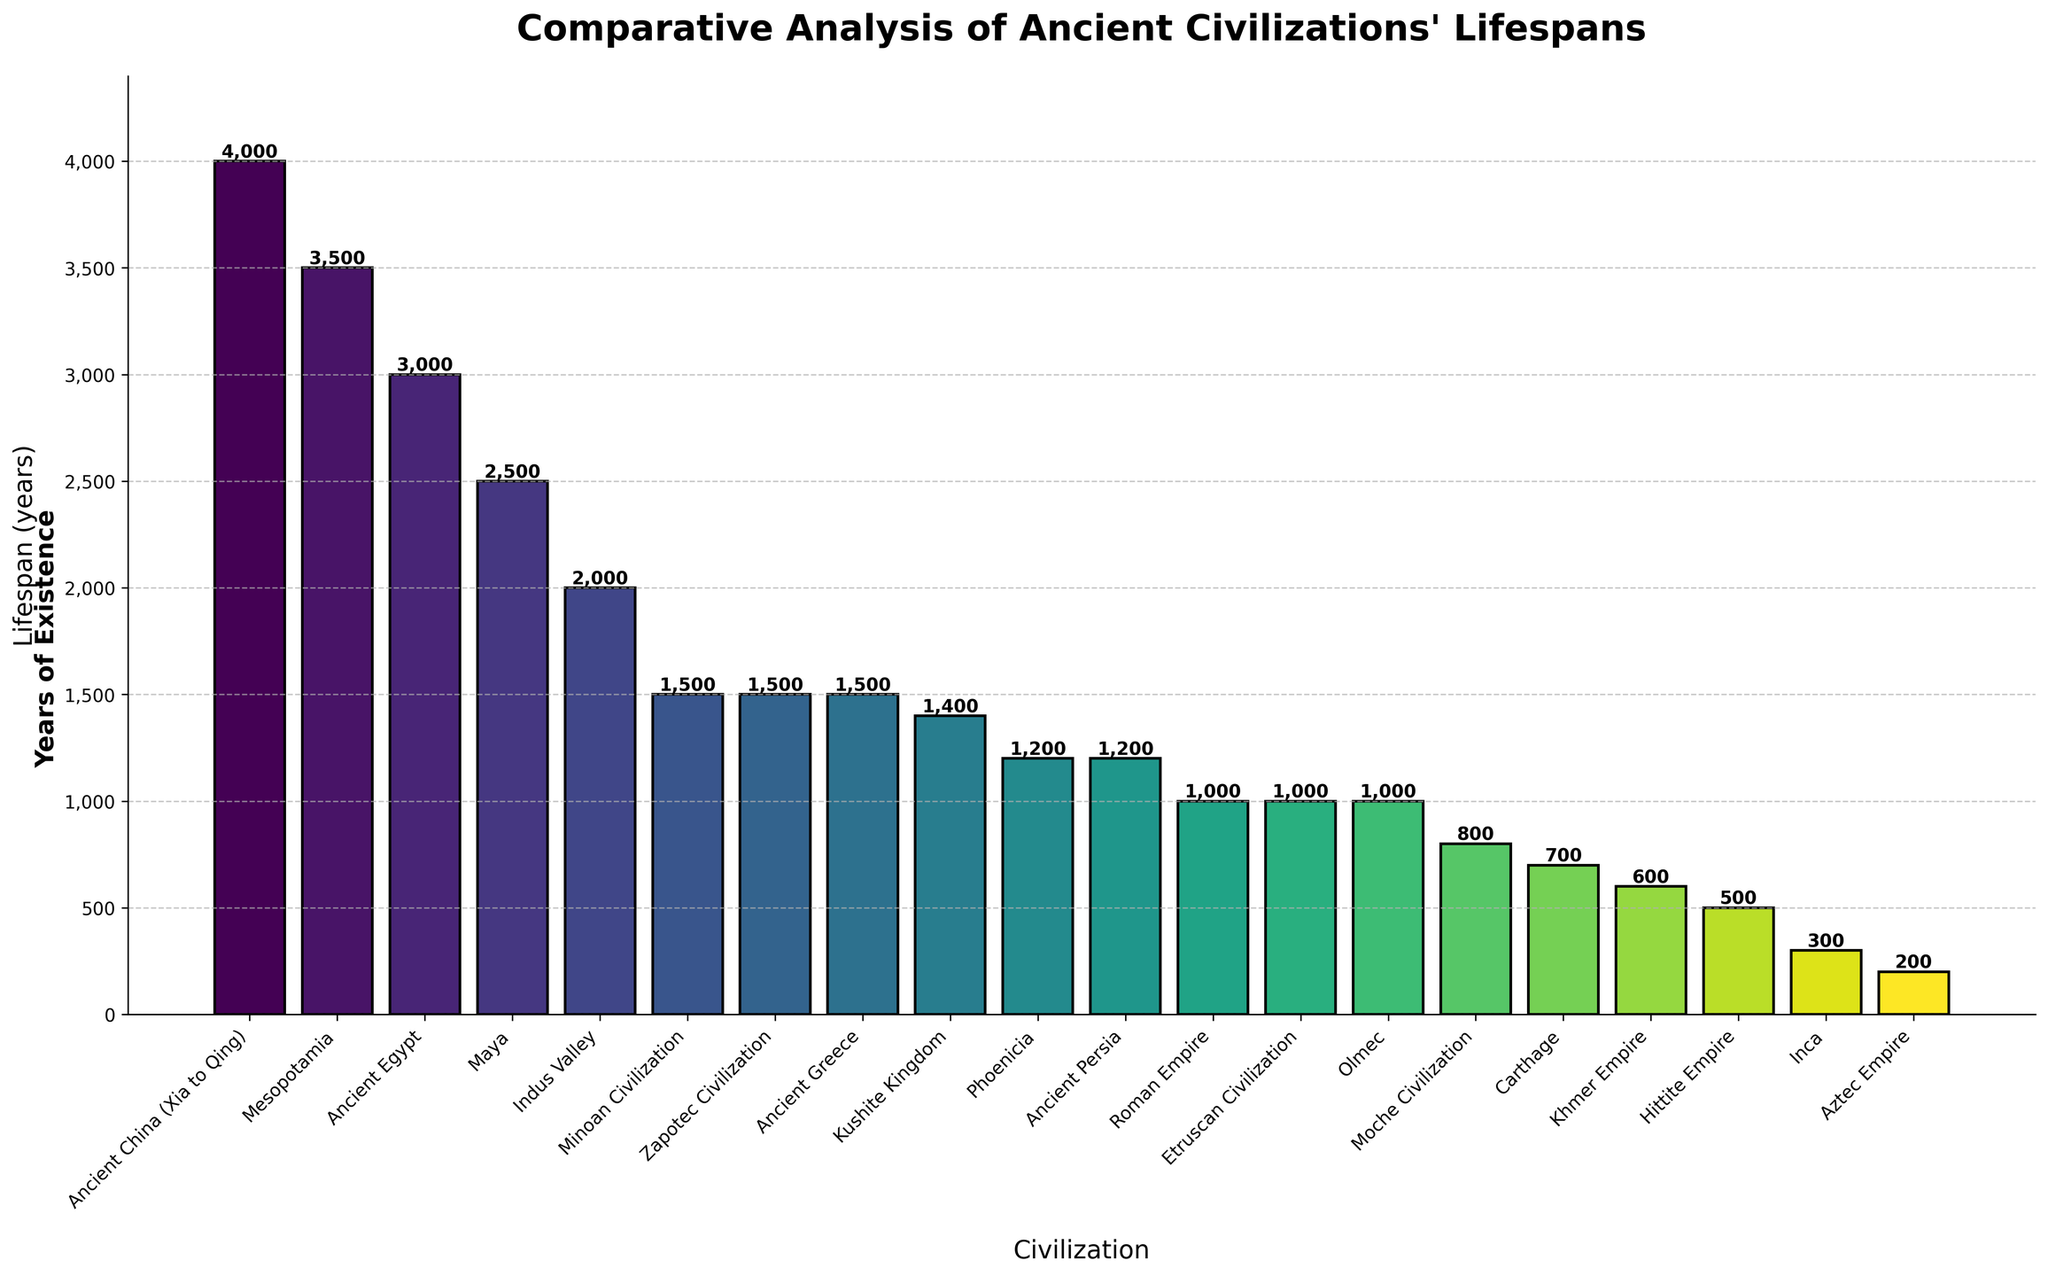What civilization has the longest lifespan according to the figure? By looking at the height of the bars, we can see that Ancient China has the tallest bar, indicating the longest lifespan.
Answer: Ancient China Which civilization has a shorter lifespan: Ancient Egypt or Roman Empire? Comparing the bars for Ancient Egypt and Roman Empire, we see that the bar for Roman Empire is shorter. Hence, Roman Empire has a shorter lifespan.
Answer: Roman Empire What is the combined lifespan of the Inca and Aztec Empires? The lifespan of the Inca Empire is 300 years and the Aztec Empire is 200 years. Adding these values, we get 300 + 200 = 500 years.
Answer: 500 years Which civilizations have a lifespan of exactly 1500 years? By checking the heights of the bars, we can identify that Ancient Greece, Minoan Civilization, and Zapotec Civilization each have lifespans of 1500 years.
Answer: Ancient Greece, Minoan Civilization, Zapotec Civilization What is the difference in lifespan between Mesopotamia and the Kushite Kingdom? The lifespan of Mesopotamia is 3500 years and that of the Kushite Kingdom is 1400 years. Subtracting these, we get 3500 - 1400 = 2100 years.
Answer: 2100 years Which civilization has a longer lifespan: Phoenicia or Ancient Persia? The bars for Phoenicia and Ancient Persia both indicate 1200 years. Hence, they have equal lifespans.
Answer: They are equal Which civilizations have lifespans greater than 3000 years? The bars for Ancient Egypt, Mesopotamia, and Ancient China are all above 3000 years.
Answer: Ancient Egypt, Mesopotamia, Ancient China How many civilizations have a lifespan less than 1000 years? From the figure, we count the civilizations with bars less than 1000. These are Inca, Hittite Empire, Aztec Empire, Carthage, Khmer Empire, and Moche Civilization. That's a total of 6 civilizations.
Answer: 6 What is the average lifespan of Ancient Egypt, Mesopotamia, and Indus Valley civilizations combined? The lifespans are 3000, 3500, and 2000 years respectively. Summing these gives 3000 + 3500 + 2000 = 8500, and the average is 8500 / 3 ≈ 2833.33 years.
Answer: 2833 years What is the lifespan range of the civilizations shown? The range is the difference between the longest and shortest lifespans. The longest is Ancient China with 4000 years, and the shortest is Aztec Empire with 200 years. So the range is 4000 - 200 = 3800 years.
Answer: 3800 years 